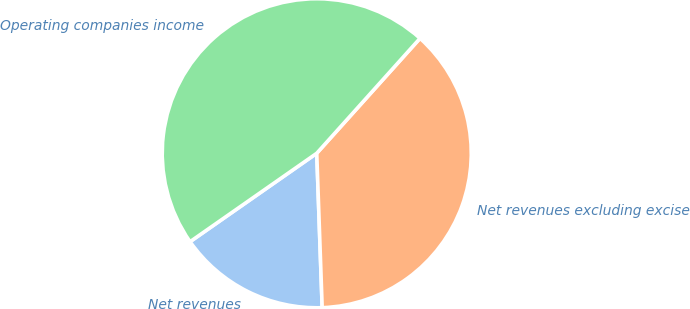Convert chart to OTSL. <chart><loc_0><loc_0><loc_500><loc_500><pie_chart><fcel>Net revenues<fcel>Net revenues excluding excise<fcel>Operating companies income<nl><fcel>15.86%<fcel>37.79%<fcel>46.35%<nl></chart> 